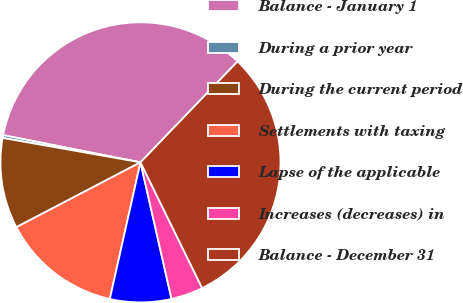Convert chart to OTSL. <chart><loc_0><loc_0><loc_500><loc_500><pie_chart><fcel>Balance - January 1<fcel>During a prior year<fcel>During the current period<fcel>Settlements with taxing<fcel>Lapse of the applicable<fcel>Increases (decreases) in<fcel>Balance - December 31<nl><fcel>34.07%<fcel>0.33%<fcel>10.45%<fcel>13.82%<fcel>7.07%<fcel>3.7%<fcel>30.55%<nl></chart> 